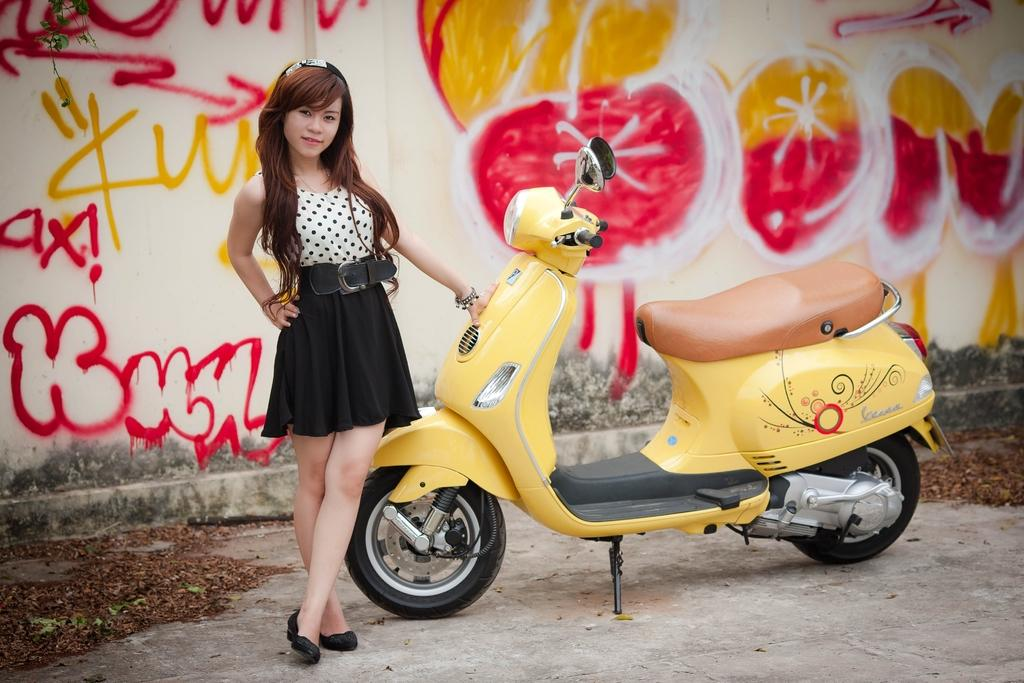Who is present in the image? There is a woman in the image. What is the woman standing beside? The woman is standing beside a scooter. What can be seen in the background of the image? There is a wall in the background of the image. What is on the wall? The wall has text and a design on it. What type of ornament is hanging from the scooter in the image? There is no ornament hanging from the scooter in the image. Is there a party happening in the image? There is no indication of a party in the image; it simply shows a woman standing beside a scooter with a wall in the background. 